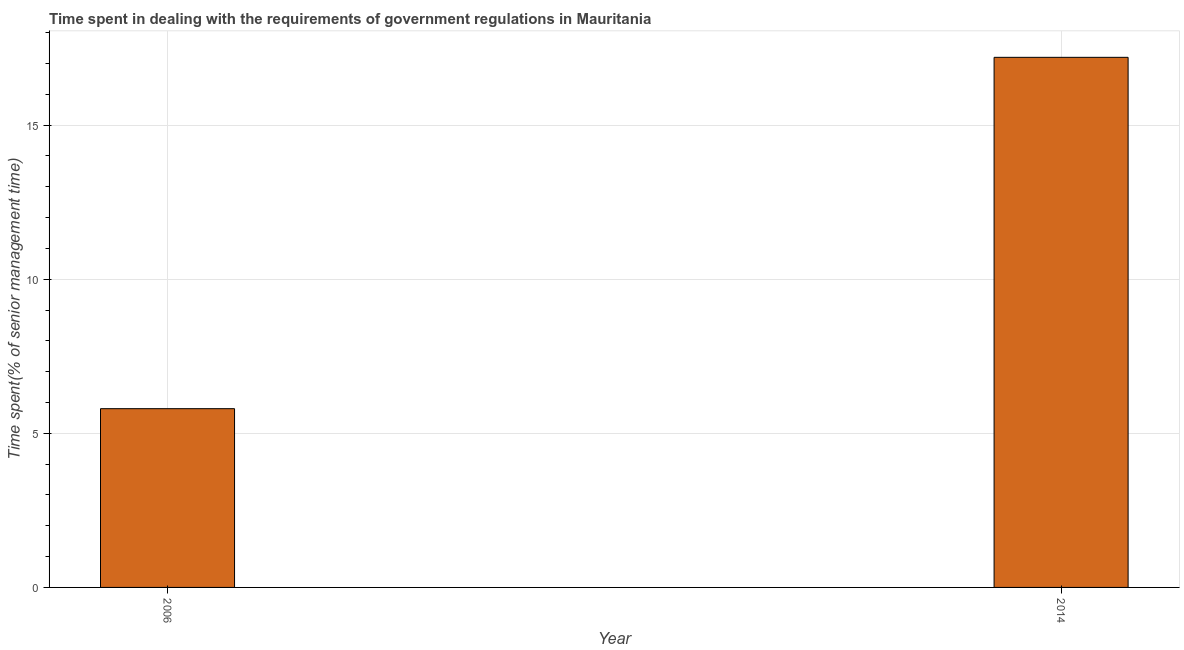Does the graph contain grids?
Keep it short and to the point. Yes. What is the title of the graph?
Your answer should be compact. Time spent in dealing with the requirements of government regulations in Mauritania. What is the label or title of the Y-axis?
Give a very brief answer. Time spent(% of senior management time). What is the time spent in dealing with government regulations in 2014?
Your answer should be compact. 17.2. Across all years, what is the minimum time spent in dealing with government regulations?
Your answer should be compact. 5.8. In which year was the time spent in dealing with government regulations maximum?
Your answer should be very brief. 2014. What is the sum of the time spent in dealing with government regulations?
Make the answer very short. 23. What is the difference between the time spent in dealing with government regulations in 2006 and 2014?
Keep it short and to the point. -11.4. What is the average time spent in dealing with government regulations per year?
Make the answer very short. 11.5. In how many years, is the time spent in dealing with government regulations greater than 6 %?
Ensure brevity in your answer.  1. Do a majority of the years between 2014 and 2006 (inclusive) have time spent in dealing with government regulations greater than 11 %?
Provide a succinct answer. No. What is the ratio of the time spent in dealing with government regulations in 2006 to that in 2014?
Your response must be concise. 0.34. In how many years, is the time spent in dealing with government regulations greater than the average time spent in dealing with government regulations taken over all years?
Your response must be concise. 1. How many bars are there?
Your answer should be compact. 2. Are all the bars in the graph horizontal?
Your response must be concise. No. How many years are there in the graph?
Ensure brevity in your answer.  2. Are the values on the major ticks of Y-axis written in scientific E-notation?
Keep it short and to the point. No. What is the Time spent(% of senior management time) of 2014?
Keep it short and to the point. 17.2. What is the ratio of the Time spent(% of senior management time) in 2006 to that in 2014?
Your response must be concise. 0.34. 